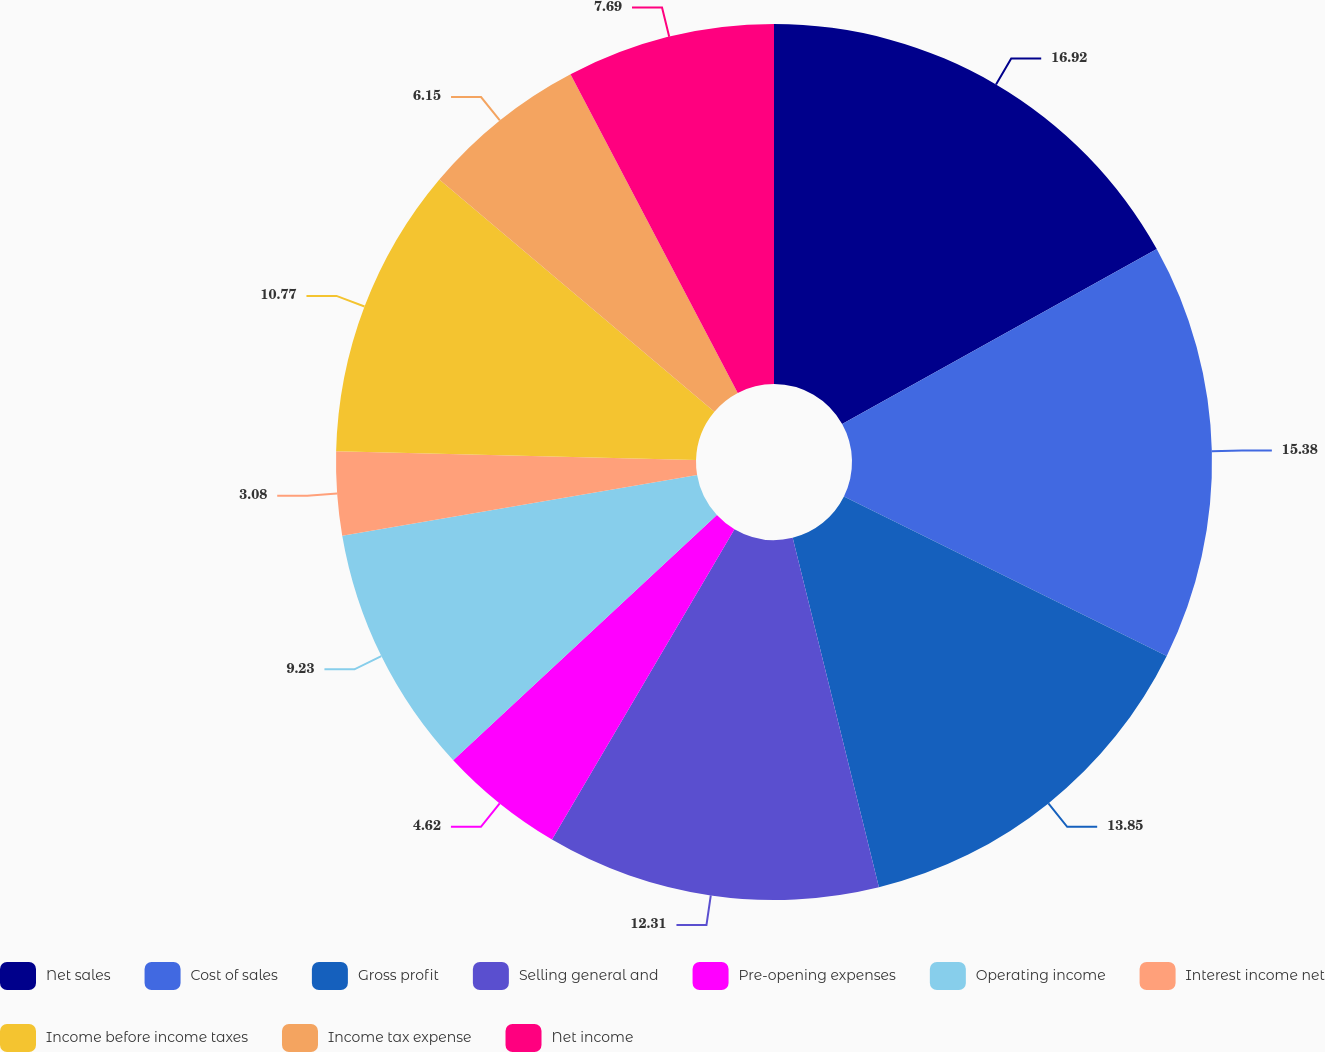Convert chart to OTSL. <chart><loc_0><loc_0><loc_500><loc_500><pie_chart><fcel>Net sales<fcel>Cost of sales<fcel>Gross profit<fcel>Selling general and<fcel>Pre-opening expenses<fcel>Operating income<fcel>Interest income net<fcel>Income before income taxes<fcel>Income tax expense<fcel>Net income<nl><fcel>16.92%<fcel>15.38%<fcel>13.85%<fcel>12.31%<fcel>4.62%<fcel>9.23%<fcel>3.08%<fcel>10.77%<fcel>6.15%<fcel>7.69%<nl></chart> 